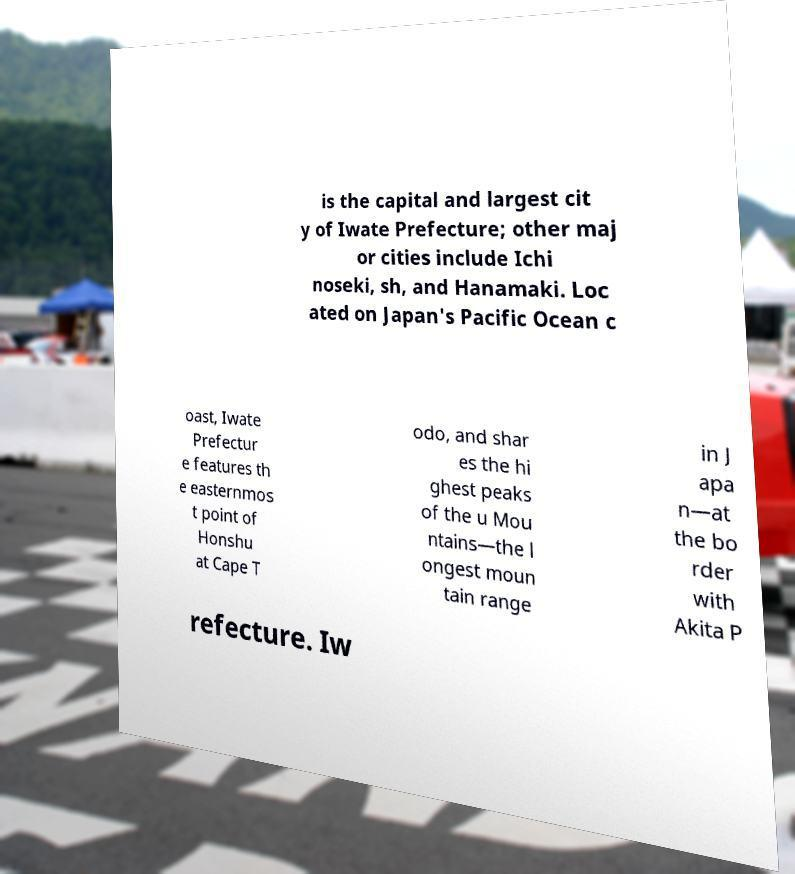Can you read and provide the text displayed in the image?This photo seems to have some interesting text. Can you extract and type it out for me? is the capital and largest cit y of Iwate Prefecture; other maj or cities include Ichi noseki, sh, and Hanamaki. Loc ated on Japan's Pacific Ocean c oast, Iwate Prefectur e features th e easternmos t point of Honshu at Cape T odo, and shar es the hi ghest peaks of the u Mou ntains—the l ongest moun tain range in J apa n—at the bo rder with Akita P refecture. Iw 